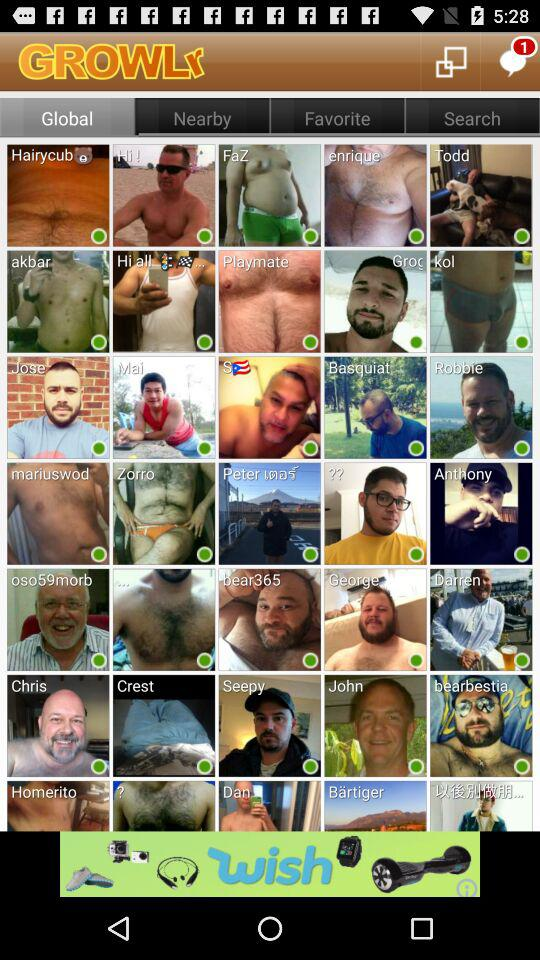What is the location?
When the provided information is insufficient, respond with <no answer>. <no answer> 